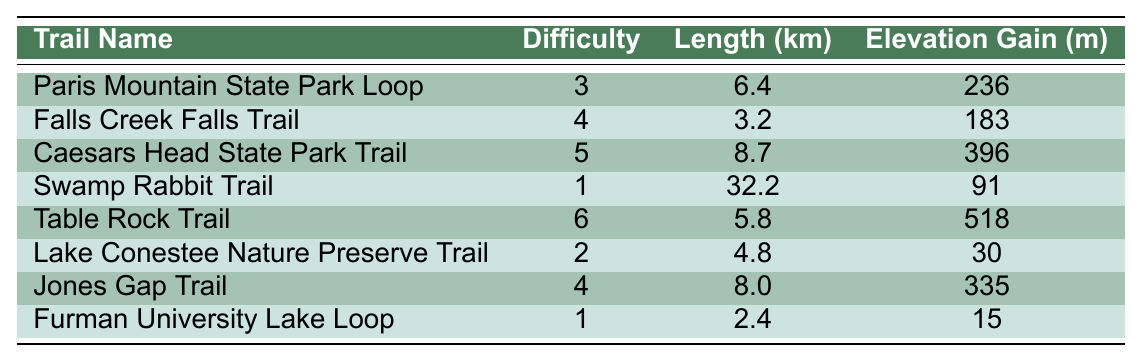What is the length of the Swamp Rabbit Trail? The table lists the Swamp Rabbit Trail under the trail name, and its corresponding length is shown in the Length column. According to the table, the Swamp Rabbit Trail is 32.2 km long.
Answer: 32.2 km Which trail has the highest difficulty rating? By examining the Difficulty column in the table, we can see that the Table Rock Trail has the highest rating, which is 6.
Answer: Table Rock Trail How much elevation gain is there on the Caesars Head State Park Trail? The table specifies the elevation gain for the Caesars Head State Park Trail in the Elevation Gain column, which indicates an elevation gain of 396 meters.
Answer: 396 meters What is the average difficulty rating of the trails listed? To calculate the average difficulty, first sum the difficulty ratings of all trails: (3 + 4 + 5 + 1 + 6 + 2 + 4 + 1) = 26. There are 8 trails, so the average difficulty is 26/8 = 3.25.
Answer: 3.25 Are there any trails that have a difficulty rating of 1? The table shows a difficulty rating of 1 for both the Swamp Rabbit Trail and the Furman University Lake Loop, confirming that there are indeed trails with this rating.
Answer: Yes Which trail is the shortest in length and what is its length? The table lists all the trails with their lengths. The shortest one is the Furman University Lake Loop, with a length of 2.4 km.
Answer: 2.4 km What is the total elevation gain for all the trails combined? To find the total elevation gain, add the elevation gains of all the trails: (236 + 183 + 396 + 91 + 518 + 30 + 335 + 15) = 1804 meters, which gives the total elevation gain for all trails.
Answer: 1804 meters Which trail has a length greater than 5 km and a difficulty rating of 4? Looking at the trails in the table, Jones Gap Trail meets both criteria, as it has a length of 8.0 km and a difficulty rating of 4.
Answer: Jones Gap Trail How many trails have a length less than 5 km? By reviewing the Length column, the Furman University Lake Loop (2.4 km) and Lake Conestee Nature Preserve Trail (4.8 km) are under 5 km, resulting in two trails that meet this condition.
Answer: 2 trails Is the average length of the trails greater than 5 km? The average length is calculated by summing the lengths of all trails: (6.4 + 3.2 + 8.7 + 32.2 + 5.8 + 4.8 + 8.0 + 2.4) = 71.7 km. Dividing this by 8 trails gives an average of 71.7/8 = 8.96 km, which is greater than 5 km.
Answer: Yes 